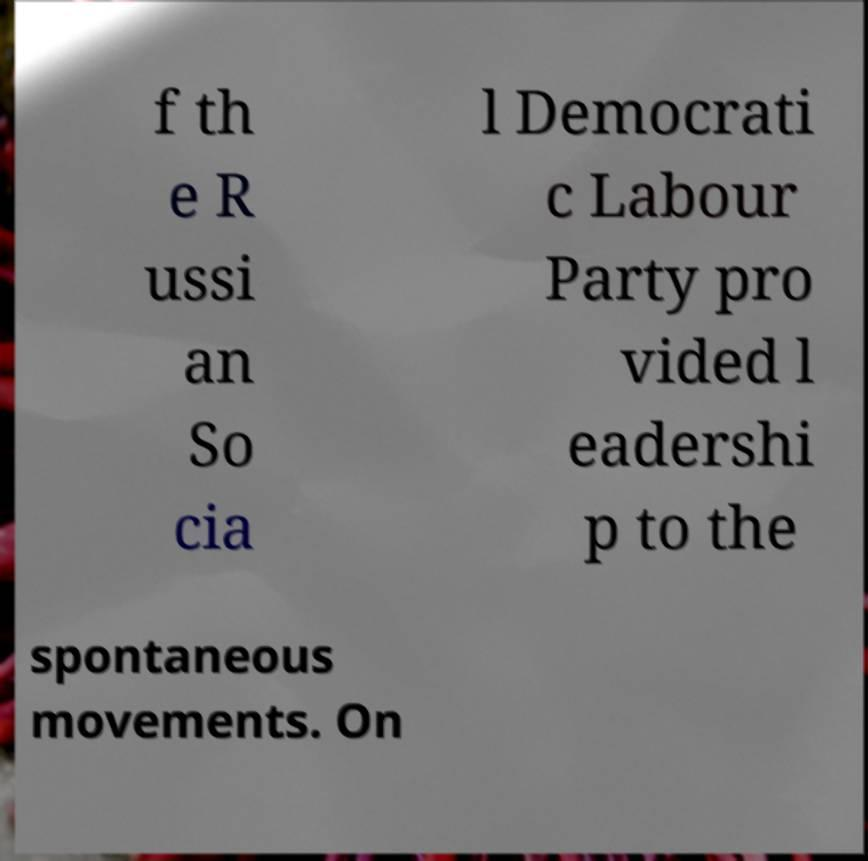What messages or text are displayed in this image? I need them in a readable, typed format. f th e R ussi an So cia l Democrati c Labour Party pro vided l eadershi p to the spontaneous movements. On 